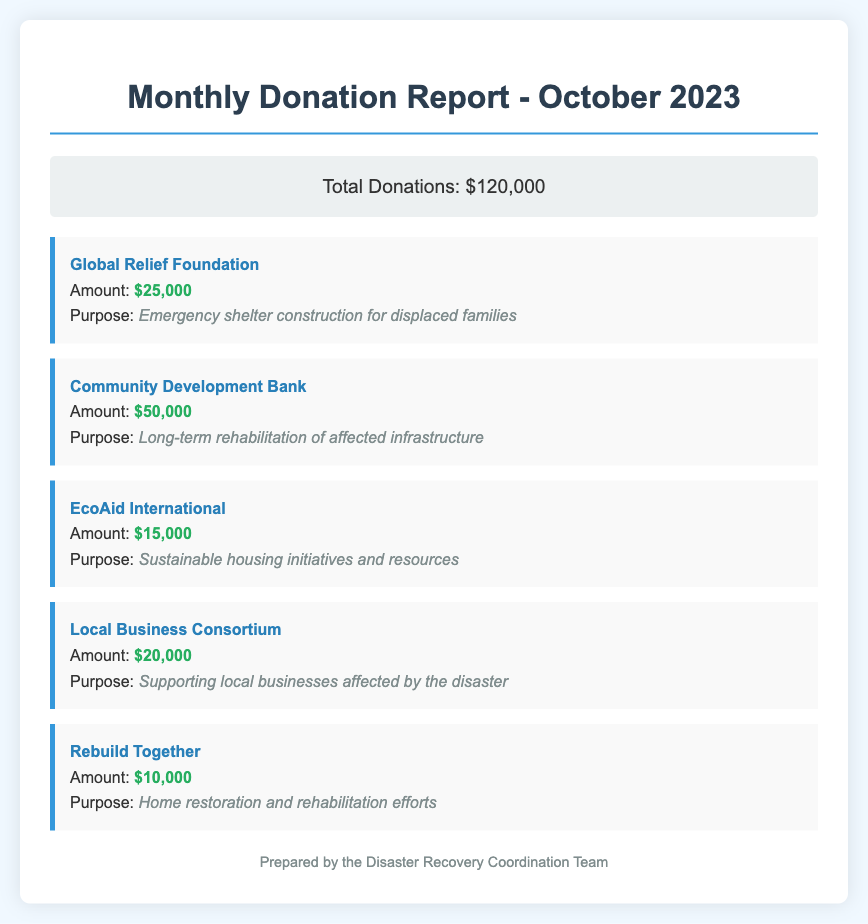What is the total amount of donations received? The total amount of donations is specified in the document as $120,000.
Answer: $120,000 Who donated the largest amount? The donor with the largest donation amount is identified as Community Development Bank, who donated $50,000.
Answer: Community Development Bank What is the purpose of the donation from EcoAid International? The purpose of EcoAid International's donation is detailed in the document as sustainable housing initiatives and resources.
Answer: Sustainable housing initiatives and resources How much did Rebuild Together contribute? The document states that Rebuild Together contributed $10,000.
Answer: $10,000 Which organization is focused on supporting local businesses? The document specifies that Local Business Consortium is dedicated to supporting local businesses affected by the disaster.
Answer: Local Business Consortium What is the total amount donated for emergency shelter construction? The document indicates that Global Relief Foundation's contribution for emergency shelter construction is $25,000.
Answer: $25,000 How many organizations contributed to the monthly report? The document lists a total of five organizations that made contributions.
Answer: Five Which donation has the lowest amount? The donation with the lowest amount is from Rebuild Together, which is $10,000.
Answer: $10,000 What type of report is this document? The document type is a Monthly Donation Report.
Answer: Monthly Donation Report 